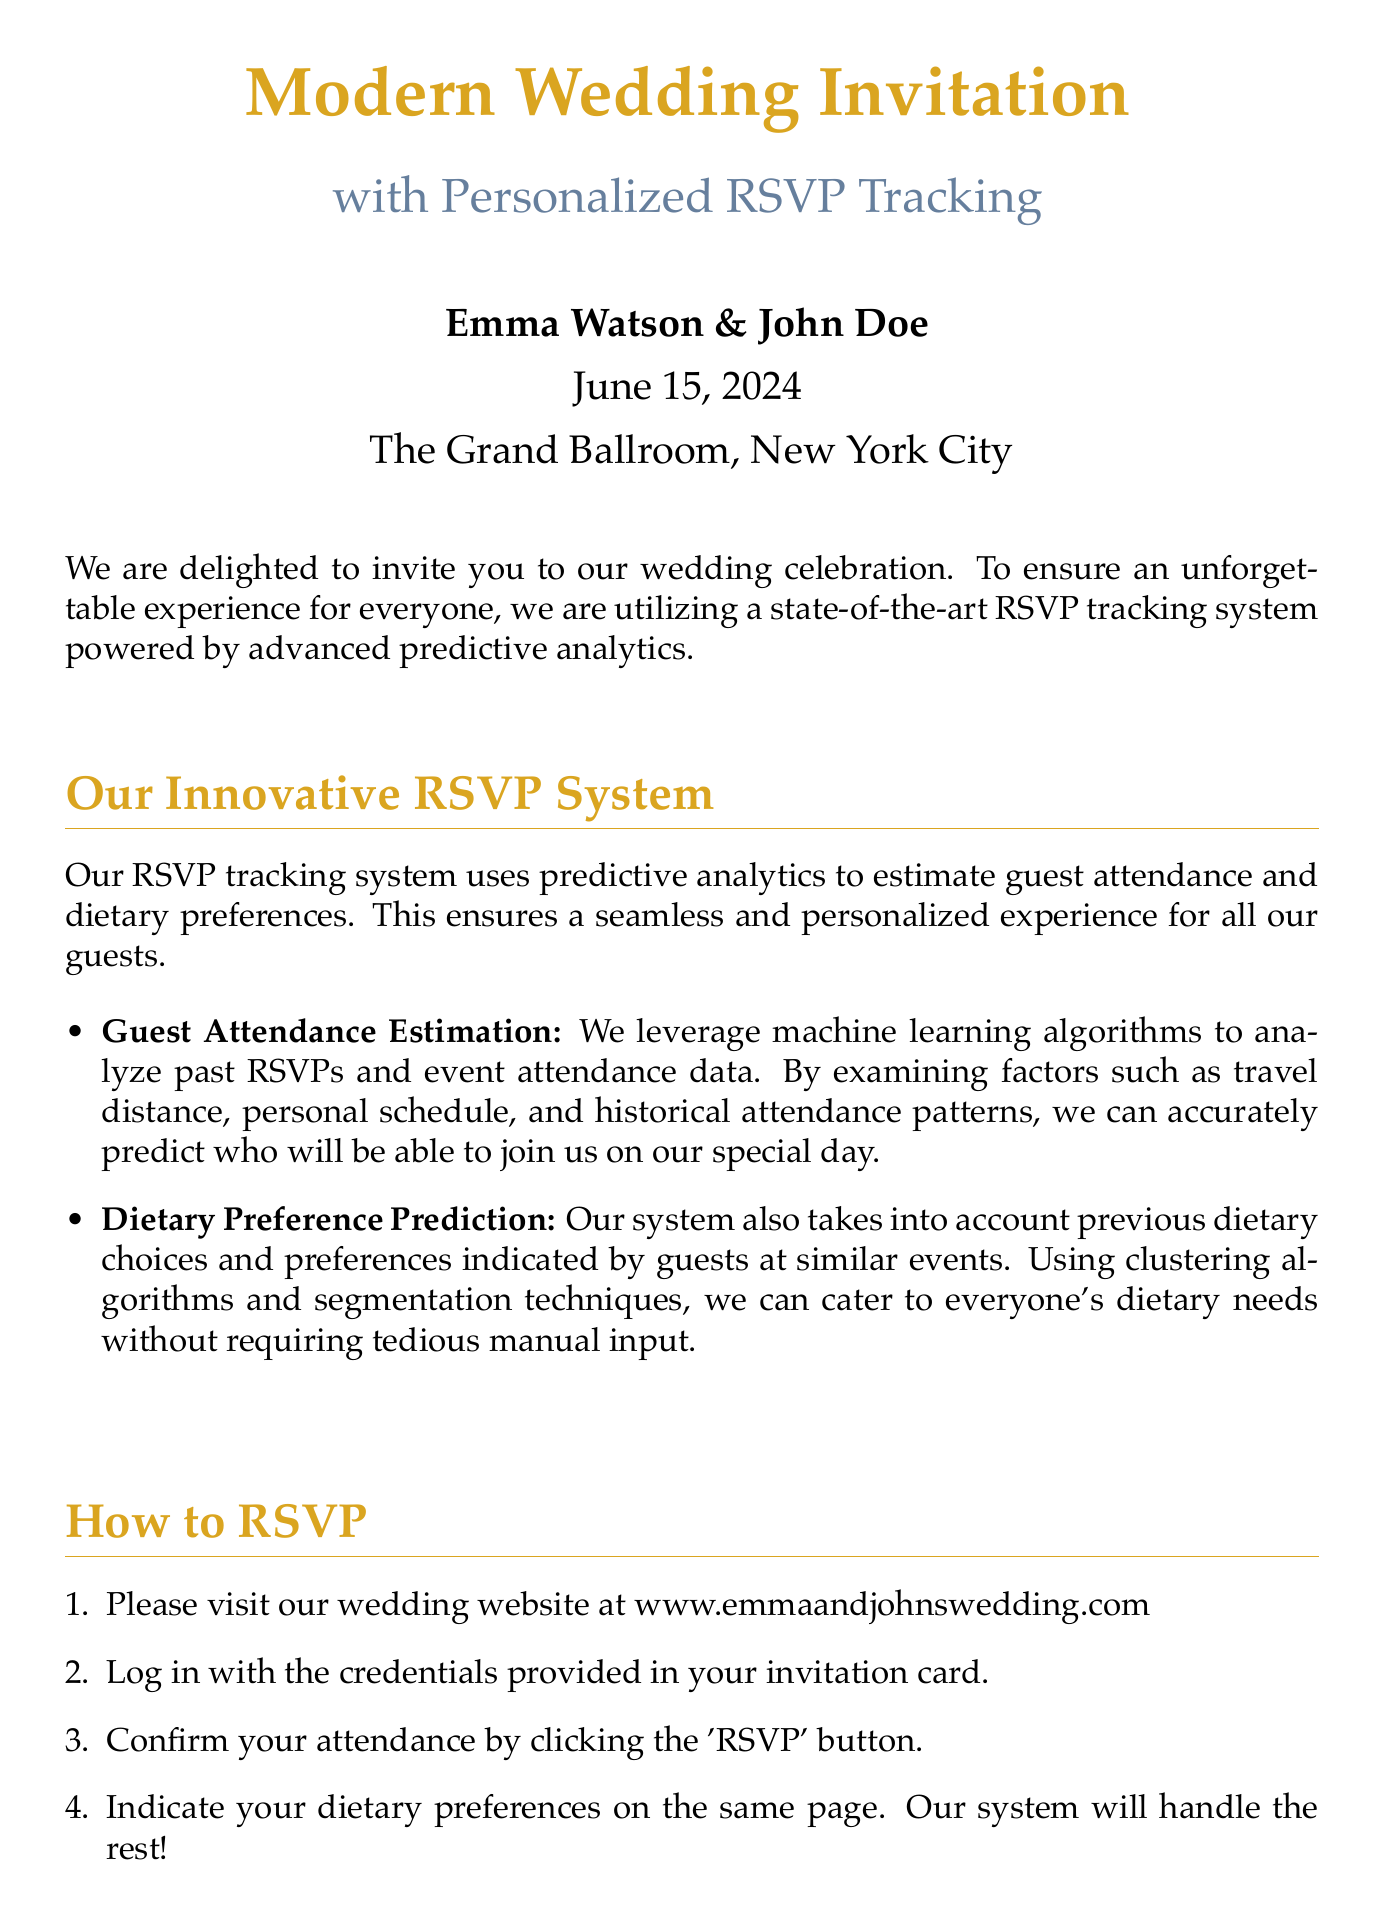what is the date of the wedding? The date of the wedding is explicitly mentioned in the document, which is June 15, 2024.
Answer: June 15, 2024 who are the couple getting married? The couple getting married is identified in the document as Emma Watson and John Doe.
Answer: Emma Watson & John Doe where is the wedding celebration taking place? The document specifies the location of the wedding as The Grand Ballroom, New York City.
Answer: The Grand Ballroom, New York City what technology is being used for RSVPs? The system used for RSVPs is described as a state-of-the-art RSVP tracking system powered by advanced predictive analytics.
Answer: predictive analytics how can guests indicate their dietary preferences? The guests can indicate their dietary preferences on the RSVP page after confirming their attendance, as stated in the document.
Answer: RSVP page what method does the RSVP system use to estimate attendance? The RSVP system leverages machine learning algorithms to analyze past RSVPs and event attendance data for estimating attendance.
Answer: machine learning algorithms how should guests RSVP? The steps for RSVPing include visiting the wedding website, logging in, confirming attendance, and indicating dietary preferences.
Answer: wedding website what is the contact email provided for inquiries? The document lists the email for contact as emma.john.wedding@example.com.
Answer: emma.john.wedding@example.com 